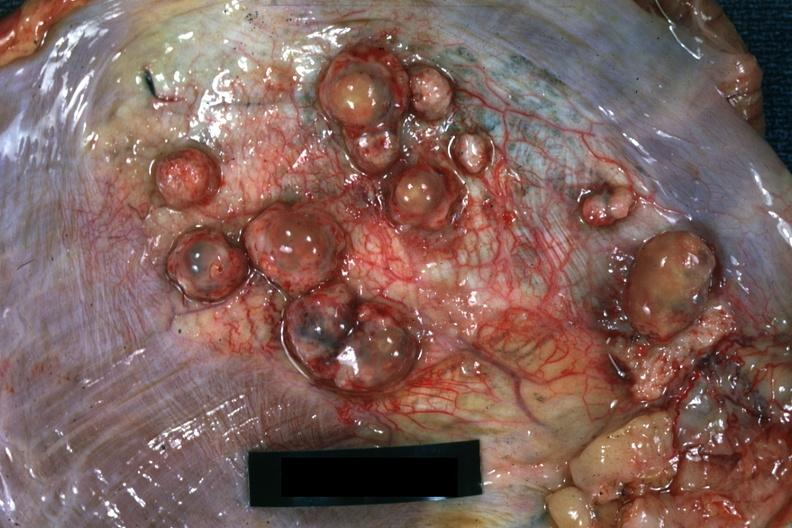what is present?
Answer the question using a single word or phrase. Muscle 